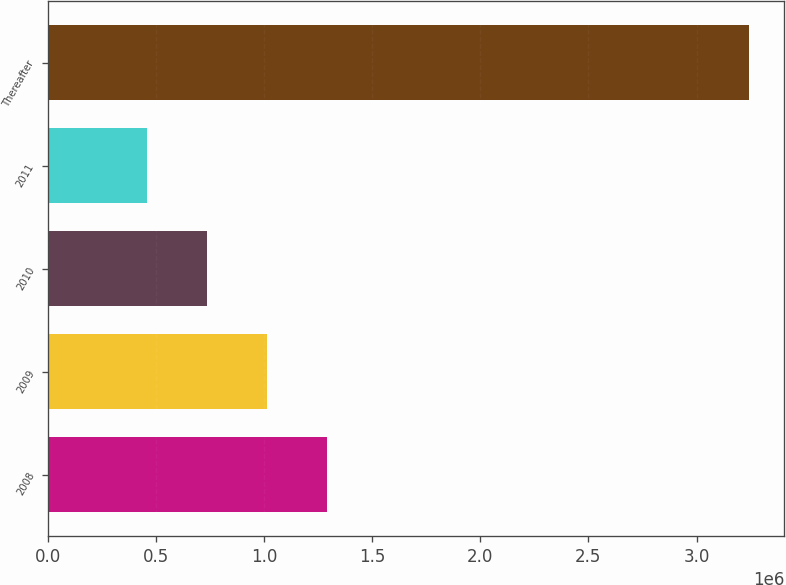Convert chart to OTSL. <chart><loc_0><loc_0><loc_500><loc_500><bar_chart><fcel>2008<fcel>2009<fcel>2010<fcel>2011<fcel>Thereafter<nl><fcel>1.29338e+06<fcel>1.01476e+06<fcel>736139<fcel>457520<fcel>3.24371e+06<nl></chart> 